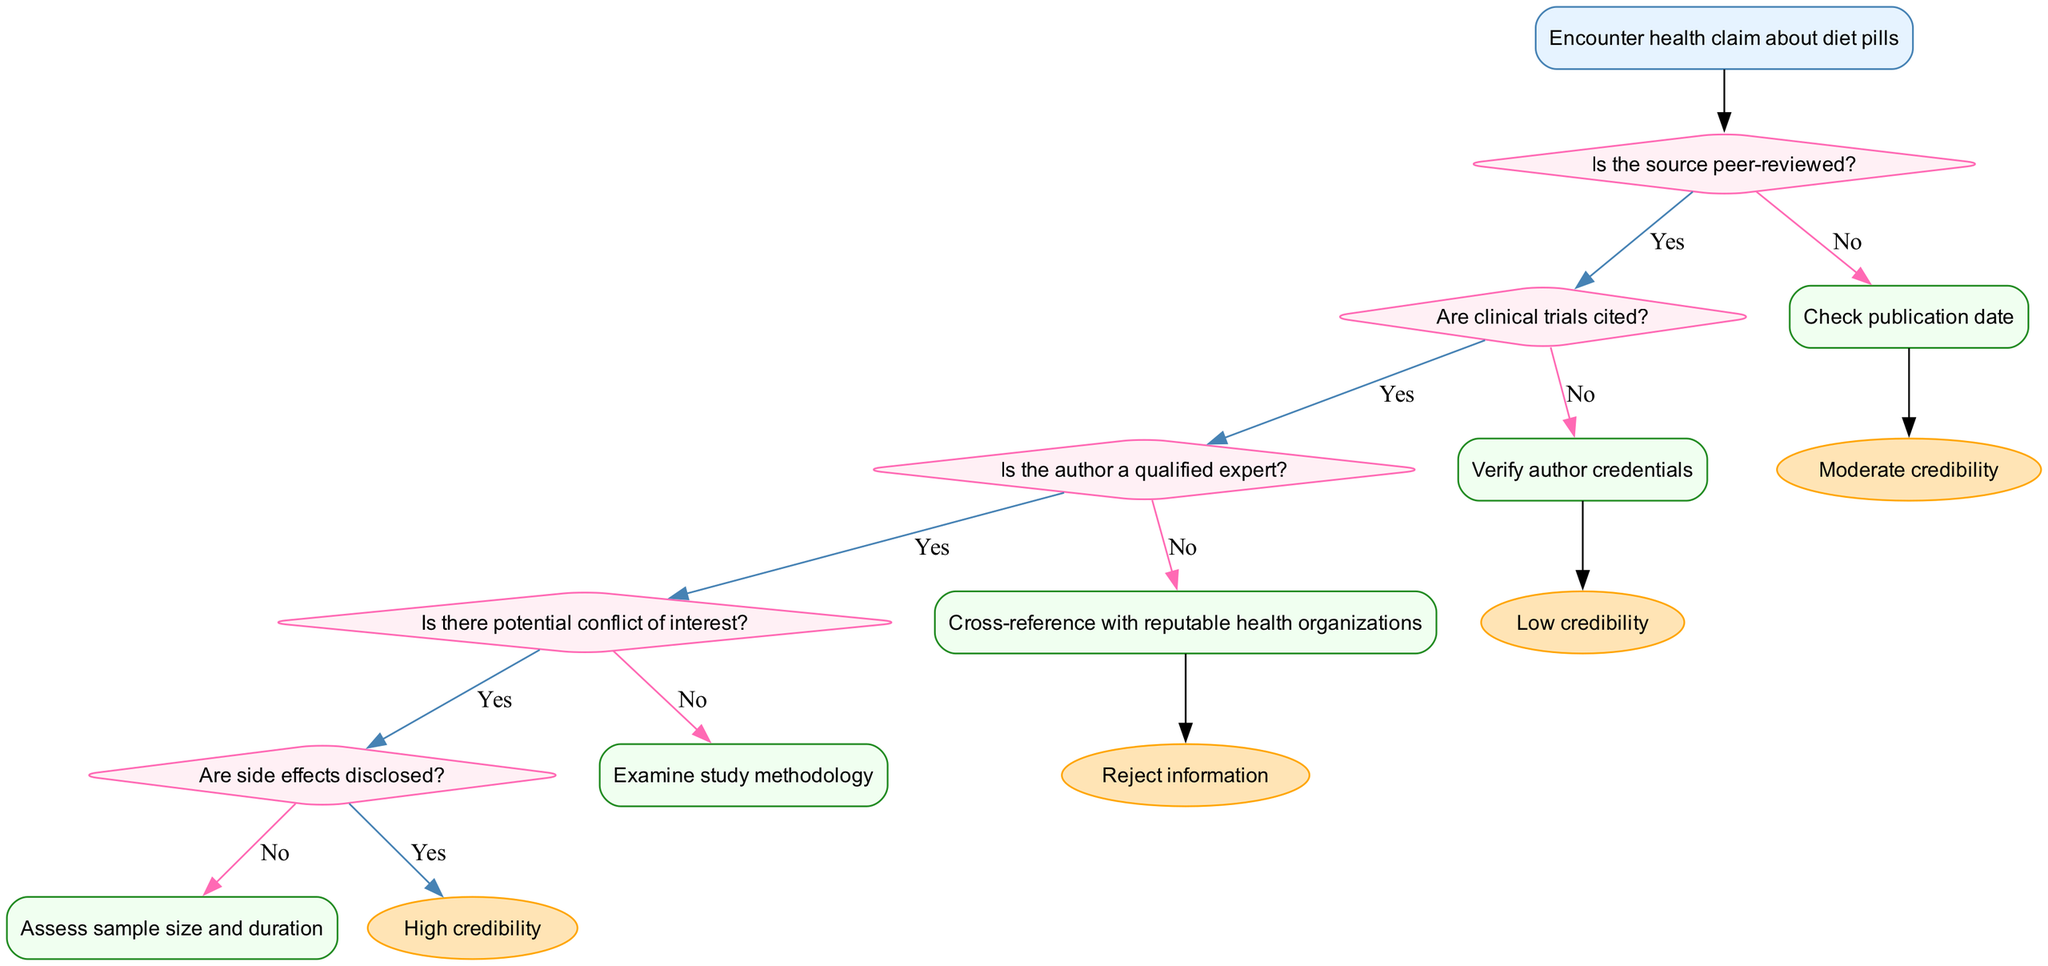What is the initial step in the flowchart? The flowchart starts with encountering a health claim about diet pills. This is indicated at the top of the diagram as the 'start' node.
Answer: Encounter health claim about diet pills How many decision nodes are present in the diagram? There are five decision nodes in the diagram, each corresponding to a question that evaluates the credibility of the health information source.
Answer: Five What happens if the source is peer-reviewed? If the source is peer-reviewed, the flow proceeds to the next decision node, continuing the evaluation process. This is represented by an edge labeled 'Yes' from the peer-reviewed decision node.
Answer: Next decision If clinical trials are not cited, what should be checked? If clinical trials are not cited, alternative criteria should be checked. This is indicated by an outgoing edge labeled 'No' leading to the next process node.
Answer: Check alternative criteria What is the outcome when a potential conflict of interest is found? A potential conflict of interest lowers the credibility of the health information, resulting in a lower credibility rating. This is reflected by the decision node's output leading to a decrease in credibility.
Answer: Lower credibility What does a large sample size indicate in the flowchart? A large sample size is associated with an increase in the credibility of the health claim. This connection is made through an edge labeled accordingly from the sample size node.
Answer: Increase credibility What is the last step if all credibility criteria are met? If all criteria for credibility are met, the flowchart indicates a 'High credibility' outcome at the end node. This is the final result of the evaluation process.
Answer: High credibility What should be done if the publication date is outdated? An outdated publication date signals caution, suggesting that the credibility of the information should be questioned or approached with skepticism.
Answer: Caution 